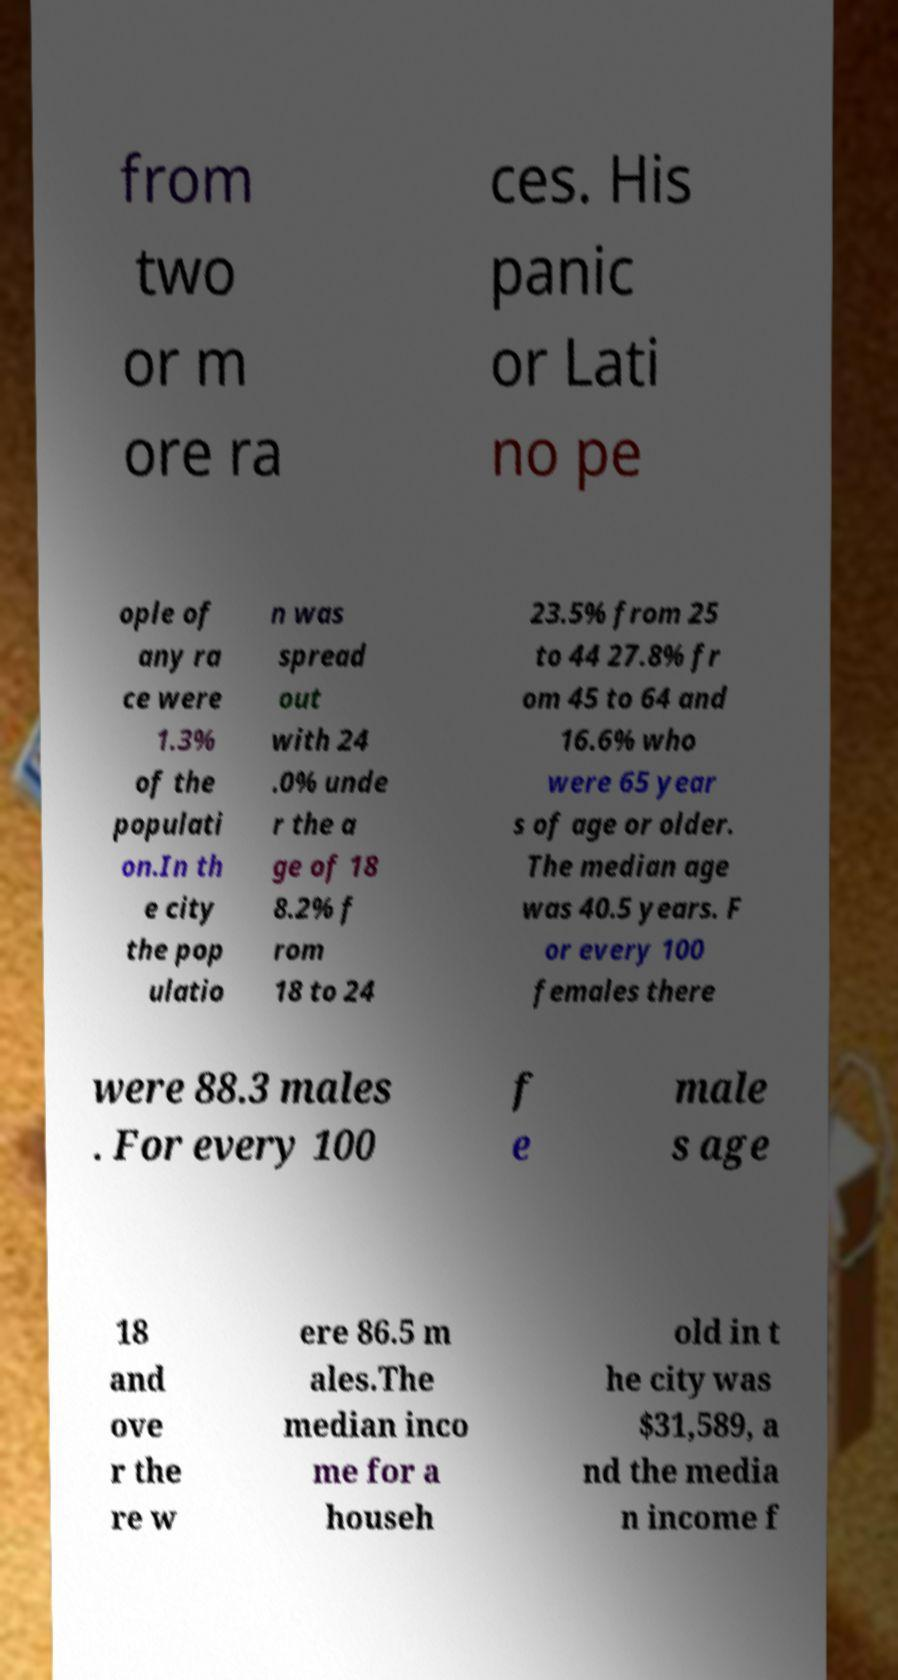What messages or text are displayed in this image? I need them in a readable, typed format. from two or m ore ra ces. His panic or Lati no pe ople of any ra ce were 1.3% of the populati on.In th e city the pop ulatio n was spread out with 24 .0% unde r the a ge of 18 8.2% f rom 18 to 24 23.5% from 25 to 44 27.8% fr om 45 to 64 and 16.6% who were 65 year s of age or older. The median age was 40.5 years. F or every 100 females there were 88.3 males . For every 100 f e male s age 18 and ove r the re w ere 86.5 m ales.The median inco me for a househ old in t he city was $31,589, a nd the media n income f 